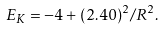<formula> <loc_0><loc_0><loc_500><loc_500>E _ { K } = - 4 + ( 2 . 4 0 ) ^ { 2 } / R ^ { 2 } .</formula> 